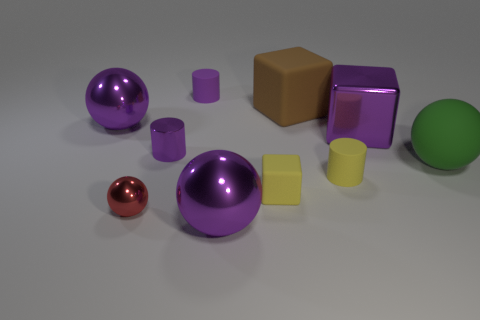How many purple balls must be subtracted to get 1 purple balls? 1 Subtract all matte balls. How many balls are left? 3 Subtract all cylinders. How many objects are left? 7 Subtract 2 balls. How many balls are left? 2 Subtract all purple balls. How many red cylinders are left? 0 Subtract all green cylinders. Subtract all tiny red metallic objects. How many objects are left? 9 Add 1 tiny red balls. How many tiny red balls are left? 2 Add 6 large cyan shiny balls. How many large cyan shiny balls exist? 6 Subtract all yellow cylinders. How many cylinders are left? 2 Subtract 0 blue spheres. How many objects are left? 10 